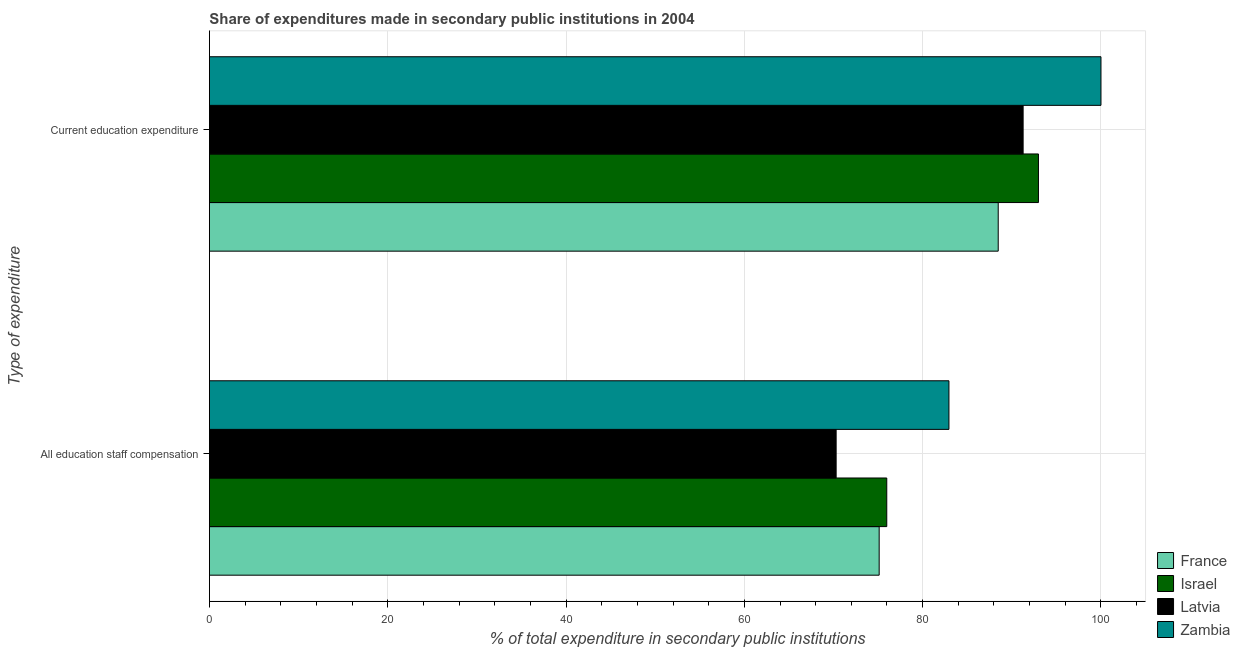How many groups of bars are there?
Your answer should be compact. 2. Are the number of bars on each tick of the Y-axis equal?
Make the answer very short. Yes. How many bars are there on the 2nd tick from the bottom?
Give a very brief answer. 4. What is the label of the 2nd group of bars from the top?
Provide a short and direct response. All education staff compensation. What is the expenditure in staff compensation in Latvia?
Your answer should be very brief. 70.3. Across all countries, what is the maximum expenditure in staff compensation?
Your answer should be very brief. 82.95. Across all countries, what is the minimum expenditure in staff compensation?
Your response must be concise. 70.3. In which country was the expenditure in staff compensation maximum?
Your answer should be very brief. Zambia. In which country was the expenditure in staff compensation minimum?
Give a very brief answer. Latvia. What is the total expenditure in staff compensation in the graph?
Provide a short and direct response. 304.34. What is the difference between the expenditure in education in Latvia and that in France?
Give a very brief answer. 2.79. What is the difference between the expenditure in staff compensation in Israel and the expenditure in education in Zambia?
Your answer should be very brief. -24.03. What is the average expenditure in staff compensation per country?
Your answer should be compact. 76.09. What is the difference between the expenditure in staff compensation and expenditure in education in Latvia?
Give a very brief answer. -20.97. What is the ratio of the expenditure in education in Zambia to that in Latvia?
Ensure brevity in your answer.  1.1. What does the 1st bar from the top in All education staff compensation represents?
Give a very brief answer. Zambia. How many bars are there?
Offer a terse response. 8. Are all the bars in the graph horizontal?
Keep it short and to the point. Yes. What is the difference between two consecutive major ticks on the X-axis?
Keep it short and to the point. 20. Are the values on the major ticks of X-axis written in scientific E-notation?
Offer a very short reply. No. Does the graph contain any zero values?
Ensure brevity in your answer.  No. Does the graph contain grids?
Give a very brief answer. Yes. How many legend labels are there?
Provide a short and direct response. 4. What is the title of the graph?
Keep it short and to the point. Share of expenditures made in secondary public institutions in 2004. What is the label or title of the X-axis?
Your answer should be compact. % of total expenditure in secondary public institutions. What is the label or title of the Y-axis?
Offer a terse response. Type of expenditure. What is the % of total expenditure in secondary public institutions in France in All education staff compensation?
Offer a very short reply. 75.12. What is the % of total expenditure in secondary public institutions in Israel in All education staff compensation?
Give a very brief answer. 75.97. What is the % of total expenditure in secondary public institutions of Latvia in All education staff compensation?
Your response must be concise. 70.3. What is the % of total expenditure in secondary public institutions of Zambia in All education staff compensation?
Offer a terse response. 82.95. What is the % of total expenditure in secondary public institutions of France in Current education expenditure?
Your answer should be compact. 88.48. What is the % of total expenditure in secondary public institutions in Israel in Current education expenditure?
Your response must be concise. 92.99. What is the % of total expenditure in secondary public institutions of Latvia in Current education expenditure?
Give a very brief answer. 91.27. What is the % of total expenditure in secondary public institutions of Zambia in Current education expenditure?
Your answer should be compact. 100. Across all Type of expenditure, what is the maximum % of total expenditure in secondary public institutions in France?
Your response must be concise. 88.48. Across all Type of expenditure, what is the maximum % of total expenditure in secondary public institutions in Israel?
Provide a succinct answer. 92.99. Across all Type of expenditure, what is the maximum % of total expenditure in secondary public institutions in Latvia?
Ensure brevity in your answer.  91.27. Across all Type of expenditure, what is the minimum % of total expenditure in secondary public institutions of France?
Give a very brief answer. 75.12. Across all Type of expenditure, what is the minimum % of total expenditure in secondary public institutions of Israel?
Your answer should be compact. 75.97. Across all Type of expenditure, what is the minimum % of total expenditure in secondary public institutions of Latvia?
Offer a terse response. 70.3. Across all Type of expenditure, what is the minimum % of total expenditure in secondary public institutions in Zambia?
Your response must be concise. 82.95. What is the total % of total expenditure in secondary public institutions of France in the graph?
Offer a very short reply. 163.6. What is the total % of total expenditure in secondary public institutions in Israel in the graph?
Your answer should be very brief. 168.96. What is the total % of total expenditure in secondary public institutions of Latvia in the graph?
Ensure brevity in your answer.  161.57. What is the total % of total expenditure in secondary public institutions of Zambia in the graph?
Offer a very short reply. 182.95. What is the difference between the % of total expenditure in secondary public institutions of France in All education staff compensation and that in Current education expenditure?
Provide a short and direct response. -13.35. What is the difference between the % of total expenditure in secondary public institutions in Israel in All education staff compensation and that in Current education expenditure?
Ensure brevity in your answer.  -17.01. What is the difference between the % of total expenditure in secondary public institutions of Latvia in All education staff compensation and that in Current education expenditure?
Provide a succinct answer. -20.97. What is the difference between the % of total expenditure in secondary public institutions of Zambia in All education staff compensation and that in Current education expenditure?
Your answer should be compact. -17.05. What is the difference between the % of total expenditure in secondary public institutions of France in All education staff compensation and the % of total expenditure in secondary public institutions of Israel in Current education expenditure?
Offer a very short reply. -17.86. What is the difference between the % of total expenditure in secondary public institutions in France in All education staff compensation and the % of total expenditure in secondary public institutions in Latvia in Current education expenditure?
Your answer should be compact. -16.15. What is the difference between the % of total expenditure in secondary public institutions in France in All education staff compensation and the % of total expenditure in secondary public institutions in Zambia in Current education expenditure?
Your answer should be compact. -24.88. What is the difference between the % of total expenditure in secondary public institutions of Israel in All education staff compensation and the % of total expenditure in secondary public institutions of Latvia in Current education expenditure?
Your response must be concise. -15.3. What is the difference between the % of total expenditure in secondary public institutions of Israel in All education staff compensation and the % of total expenditure in secondary public institutions of Zambia in Current education expenditure?
Make the answer very short. -24.03. What is the difference between the % of total expenditure in secondary public institutions in Latvia in All education staff compensation and the % of total expenditure in secondary public institutions in Zambia in Current education expenditure?
Ensure brevity in your answer.  -29.7. What is the average % of total expenditure in secondary public institutions of France per Type of expenditure?
Your answer should be very brief. 81.8. What is the average % of total expenditure in secondary public institutions of Israel per Type of expenditure?
Provide a short and direct response. 84.48. What is the average % of total expenditure in secondary public institutions of Latvia per Type of expenditure?
Your answer should be compact. 80.78. What is the average % of total expenditure in secondary public institutions in Zambia per Type of expenditure?
Make the answer very short. 91.47. What is the difference between the % of total expenditure in secondary public institutions in France and % of total expenditure in secondary public institutions in Israel in All education staff compensation?
Make the answer very short. -0.85. What is the difference between the % of total expenditure in secondary public institutions of France and % of total expenditure in secondary public institutions of Latvia in All education staff compensation?
Provide a short and direct response. 4.83. What is the difference between the % of total expenditure in secondary public institutions of France and % of total expenditure in secondary public institutions of Zambia in All education staff compensation?
Your answer should be very brief. -7.82. What is the difference between the % of total expenditure in secondary public institutions in Israel and % of total expenditure in secondary public institutions in Latvia in All education staff compensation?
Your response must be concise. 5.68. What is the difference between the % of total expenditure in secondary public institutions in Israel and % of total expenditure in secondary public institutions in Zambia in All education staff compensation?
Offer a very short reply. -6.97. What is the difference between the % of total expenditure in secondary public institutions in Latvia and % of total expenditure in secondary public institutions in Zambia in All education staff compensation?
Provide a succinct answer. -12.65. What is the difference between the % of total expenditure in secondary public institutions in France and % of total expenditure in secondary public institutions in Israel in Current education expenditure?
Your answer should be very brief. -4.51. What is the difference between the % of total expenditure in secondary public institutions in France and % of total expenditure in secondary public institutions in Latvia in Current education expenditure?
Offer a terse response. -2.79. What is the difference between the % of total expenditure in secondary public institutions in France and % of total expenditure in secondary public institutions in Zambia in Current education expenditure?
Provide a succinct answer. -11.52. What is the difference between the % of total expenditure in secondary public institutions in Israel and % of total expenditure in secondary public institutions in Latvia in Current education expenditure?
Your answer should be very brief. 1.72. What is the difference between the % of total expenditure in secondary public institutions of Israel and % of total expenditure in secondary public institutions of Zambia in Current education expenditure?
Your answer should be very brief. -7.01. What is the difference between the % of total expenditure in secondary public institutions of Latvia and % of total expenditure in secondary public institutions of Zambia in Current education expenditure?
Your answer should be very brief. -8.73. What is the ratio of the % of total expenditure in secondary public institutions in France in All education staff compensation to that in Current education expenditure?
Your answer should be very brief. 0.85. What is the ratio of the % of total expenditure in secondary public institutions in Israel in All education staff compensation to that in Current education expenditure?
Give a very brief answer. 0.82. What is the ratio of the % of total expenditure in secondary public institutions in Latvia in All education staff compensation to that in Current education expenditure?
Your answer should be very brief. 0.77. What is the ratio of the % of total expenditure in secondary public institutions of Zambia in All education staff compensation to that in Current education expenditure?
Your answer should be compact. 0.83. What is the difference between the highest and the second highest % of total expenditure in secondary public institutions in France?
Your answer should be very brief. 13.35. What is the difference between the highest and the second highest % of total expenditure in secondary public institutions of Israel?
Provide a succinct answer. 17.01. What is the difference between the highest and the second highest % of total expenditure in secondary public institutions in Latvia?
Provide a succinct answer. 20.97. What is the difference between the highest and the second highest % of total expenditure in secondary public institutions in Zambia?
Provide a succinct answer. 17.05. What is the difference between the highest and the lowest % of total expenditure in secondary public institutions in France?
Your response must be concise. 13.35. What is the difference between the highest and the lowest % of total expenditure in secondary public institutions in Israel?
Give a very brief answer. 17.01. What is the difference between the highest and the lowest % of total expenditure in secondary public institutions in Latvia?
Your answer should be very brief. 20.97. What is the difference between the highest and the lowest % of total expenditure in secondary public institutions in Zambia?
Your answer should be very brief. 17.05. 